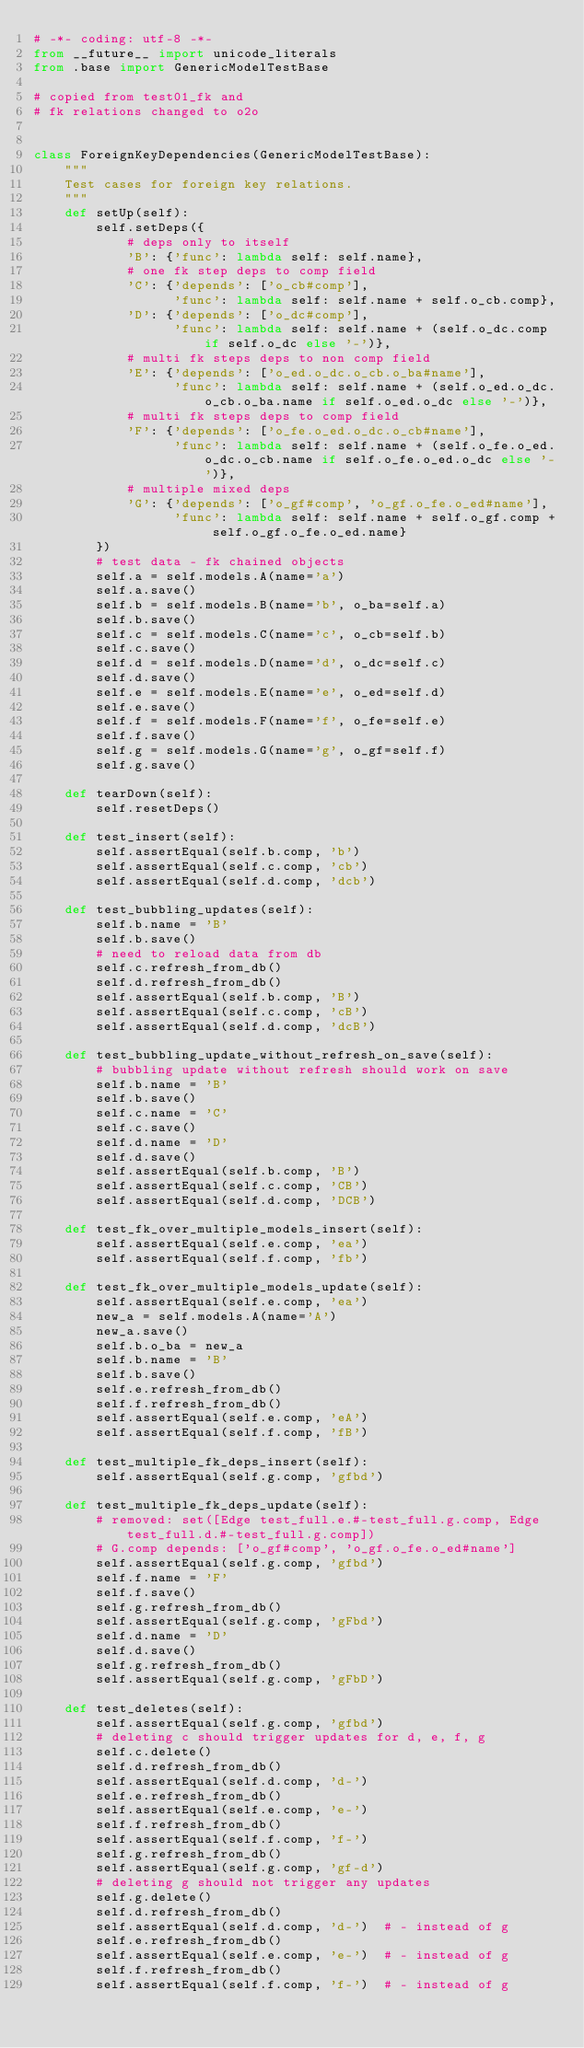Convert code to text. <code><loc_0><loc_0><loc_500><loc_500><_Python_># -*- coding: utf-8 -*-
from __future__ import unicode_literals
from .base import GenericModelTestBase

# copied from test01_fk and
# fk relations changed to o2o


class ForeignKeyDependencies(GenericModelTestBase):
    """
    Test cases for foreign key relations.
    """
    def setUp(self):
        self.setDeps({
            # deps only to itself
            'B': {'func': lambda self: self.name},
            # one fk step deps to comp field
            'C': {'depends': ['o_cb#comp'],
                  'func': lambda self: self.name + self.o_cb.comp},
            'D': {'depends': ['o_dc#comp'],
                  'func': lambda self: self.name + (self.o_dc.comp if self.o_dc else '-')},
            # multi fk steps deps to non comp field
            'E': {'depends': ['o_ed.o_dc.o_cb.o_ba#name'],
                  'func': lambda self: self.name + (self.o_ed.o_dc.o_cb.o_ba.name if self.o_ed.o_dc else '-')},
            # multi fk steps deps to comp field
            'F': {'depends': ['o_fe.o_ed.o_dc.o_cb#name'],
                  'func': lambda self: self.name + (self.o_fe.o_ed.o_dc.o_cb.name if self.o_fe.o_ed.o_dc else '-')},
            # multiple mixed deps
            'G': {'depends': ['o_gf#comp', 'o_gf.o_fe.o_ed#name'],
                  'func': lambda self: self.name + self.o_gf.comp + self.o_gf.o_fe.o_ed.name}
        })
        # test data - fk chained objects
        self.a = self.models.A(name='a')
        self.a.save()
        self.b = self.models.B(name='b', o_ba=self.a)
        self.b.save()
        self.c = self.models.C(name='c', o_cb=self.b)
        self.c.save()
        self.d = self.models.D(name='d', o_dc=self.c)
        self.d.save()
        self.e = self.models.E(name='e', o_ed=self.d)
        self.e.save()
        self.f = self.models.F(name='f', o_fe=self.e)
        self.f.save()
        self.g = self.models.G(name='g', o_gf=self.f)
        self.g.save()

    def tearDown(self):
        self.resetDeps()

    def test_insert(self):
        self.assertEqual(self.b.comp, 'b')
        self.assertEqual(self.c.comp, 'cb')
        self.assertEqual(self.d.comp, 'dcb')

    def test_bubbling_updates(self):
        self.b.name = 'B'
        self.b.save()
        # need to reload data from db
        self.c.refresh_from_db()
        self.d.refresh_from_db()
        self.assertEqual(self.b.comp, 'B')
        self.assertEqual(self.c.comp, 'cB')
        self.assertEqual(self.d.comp, 'dcB')

    def test_bubbling_update_without_refresh_on_save(self):
        # bubbling update without refresh should work on save
        self.b.name = 'B'
        self.b.save()
        self.c.name = 'C'
        self.c.save()
        self.d.name = 'D'
        self.d.save()
        self.assertEqual(self.b.comp, 'B')
        self.assertEqual(self.c.comp, 'CB')
        self.assertEqual(self.d.comp, 'DCB')

    def test_fk_over_multiple_models_insert(self):
        self.assertEqual(self.e.comp, 'ea')
        self.assertEqual(self.f.comp, 'fb')

    def test_fk_over_multiple_models_update(self):
        self.assertEqual(self.e.comp, 'ea')
        new_a = self.models.A(name='A')
        new_a.save()
        self.b.o_ba = new_a
        self.b.name = 'B'
        self.b.save()
        self.e.refresh_from_db()
        self.f.refresh_from_db()
        self.assertEqual(self.e.comp, 'eA')
        self.assertEqual(self.f.comp, 'fB')

    def test_multiple_fk_deps_insert(self):
        self.assertEqual(self.g.comp, 'gfbd')

    def test_multiple_fk_deps_update(self):
        # removed: set([Edge test_full.e.#-test_full.g.comp, Edge test_full.d.#-test_full.g.comp])
        # G.comp depends: ['o_gf#comp', 'o_gf.o_fe.o_ed#name']
        self.assertEqual(self.g.comp, 'gfbd')
        self.f.name = 'F'
        self.f.save()
        self.g.refresh_from_db()
        self.assertEqual(self.g.comp, 'gFbd')
        self.d.name = 'D'
        self.d.save()
        self.g.refresh_from_db()
        self.assertEqual(self.g.comp, 'gFbD')

    def test_deletes(self):
        self.assertEqual(self.g.comp, 'gfbd')
        # deleting c should trigger updates for d, e, f, g
        self.c.delete()
        self.d.refresh_from_db()
        self.assertEqual(self.d.comp, 'd-')
        self.e.refresh_from_db()
        self.assertEqual(self.e.comp, 'e-')
        self.f.refresh_from_db()
        self.assertEqual(self.f.comp, 'f-')
        self.g.refresh_from_db()
        self.assertEqual(self.g.comp, 'gf-d')
        # deleting g should not trigger any updates
        self.g.delete()
        self.d.refresh_from_db()
        self.assertEqual(self.d.comp, 'd-')  # - instead of g
        self.e.refresh_from_db()
        self.assertEqual(self.e.comp, 'e-')  # - instead of g
        self.f.refresh_from_db()
        self.assertEqual(self.f.comp, 'f-')  # - instead of g
</code> 